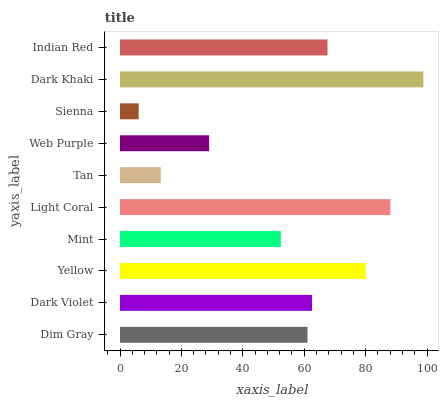Is Sienna the minimum?
Answer yes or no. Yes. Is Dark Khaki the maximum?
Answer yes or no. Yes. Is Dark Violet the minimum?
Answer yes or no. No. Is Dark Violet the maximum?
Answer yes or no. No. Is Dark Violet greater than Dim Gray?
Answer yes or no. Yes. Is Dim Gray less than Dark Violet?
Answer yes or no. Yes. Is Dim Gray greater than Dark Violet?
Answer yes or no. No. Is Dark Violet less than Dim Gray?
Answer yes or no. No. Is Dark Violet the high median?
Answer yes or no. Yes. Is Dim Gray the low median?
Answer yes or no. Yes. Is Indian Red the high median?
Answer yes or no. No. Is Mint the low median?
Answer yes or no. No. 